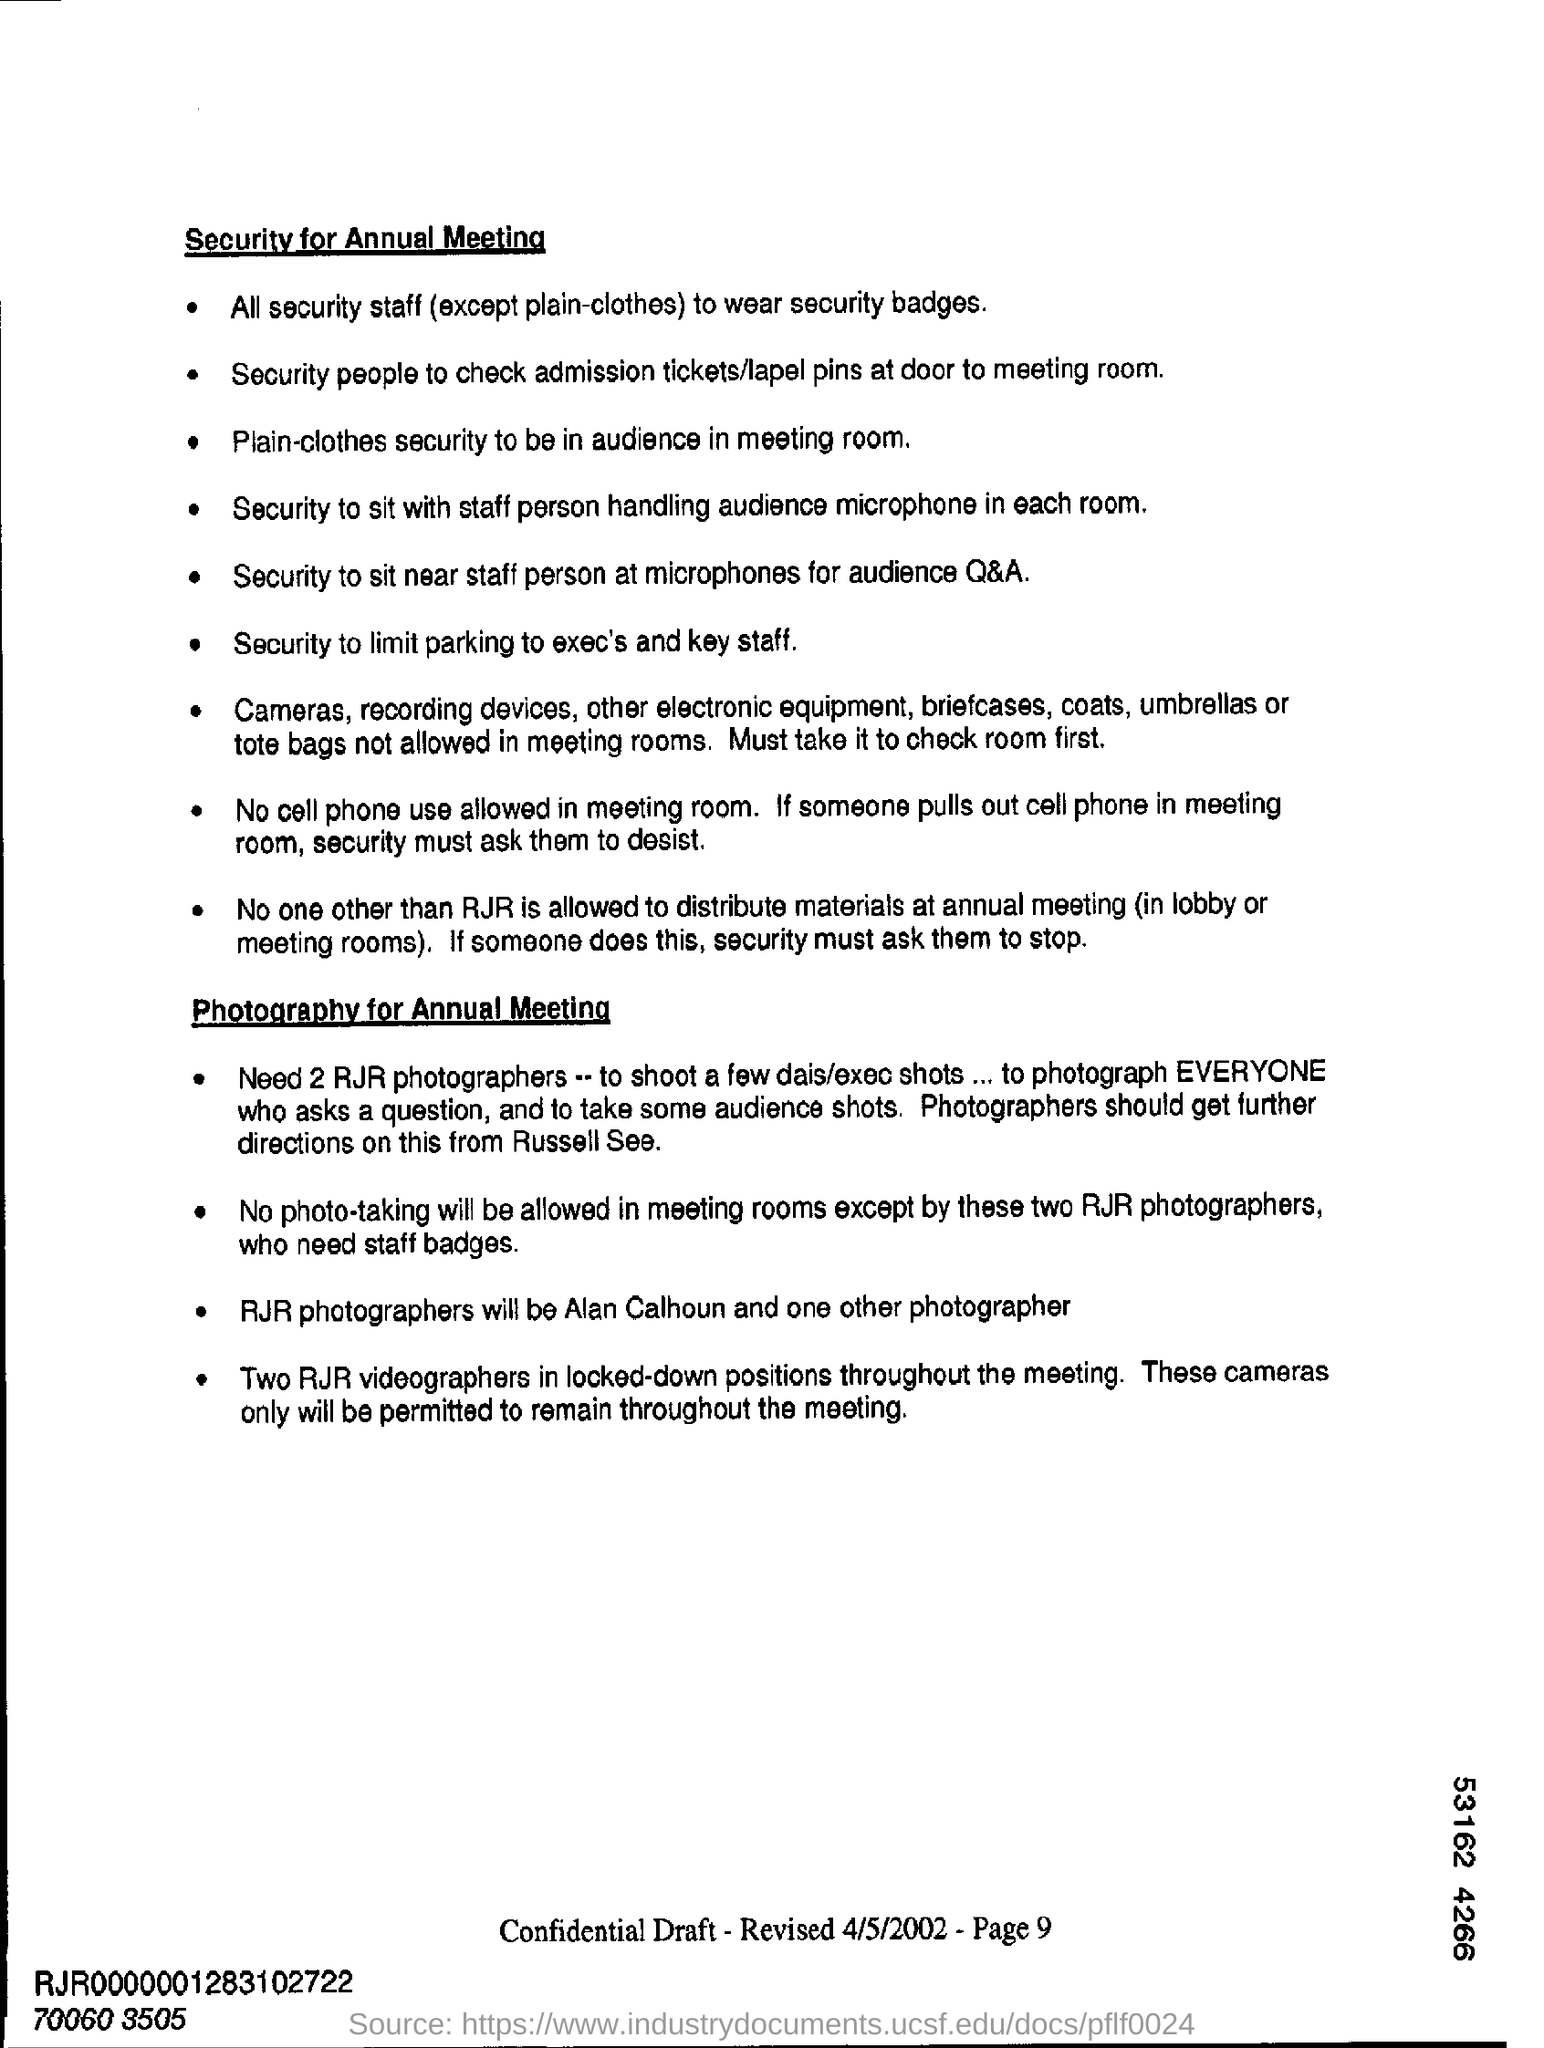Mention the page number at bottom of the page ?
Your answer should be very brief. 9. How many rjr photographers are needed?
Offer a very short reply. 2. 